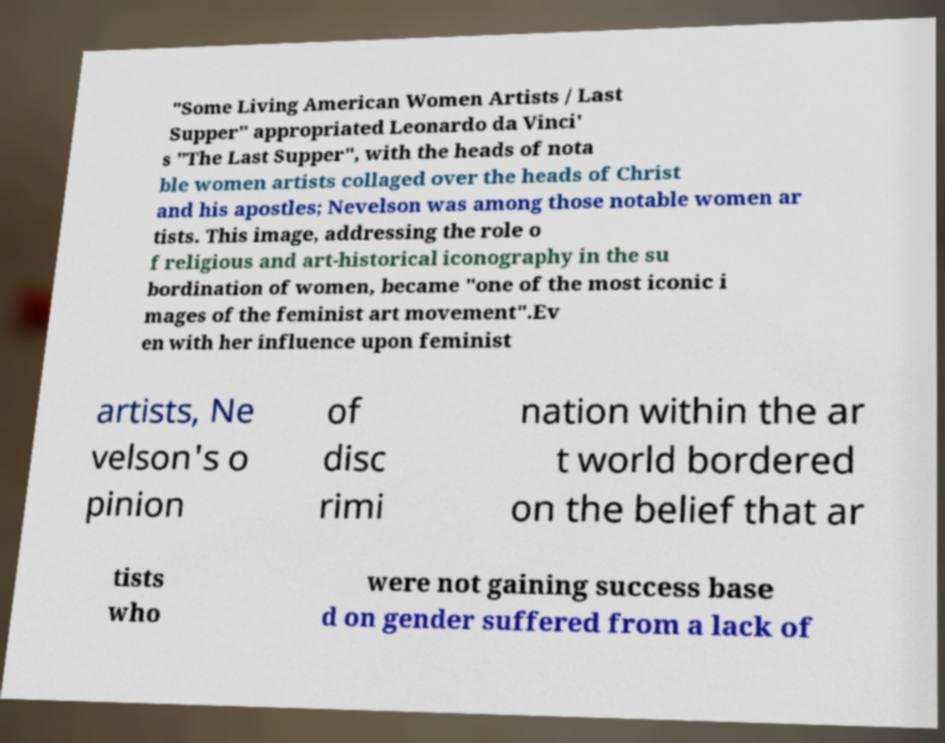Please read and relay the text visible in this image. What does it say? "Some Living American Women Artists / Last Supper" appropriated Leonardo da Vinci' s "The Last Supper", with the heads of nota ble women artists collaged over the heads of Christ and his apostles; Nevelson was among those notable women ar tists. This image, addressing the role o f religious and art-historical iconography in the su bordination of women, became "one of the most iconic i mages of the feminist art movement".Ev en with her influence upon feminist artists, Ne velson's o pinion of disc rimi nation within the ar t world bordered on the belief that ar tists who were not gaining success base d on gender suffered from a lack of 